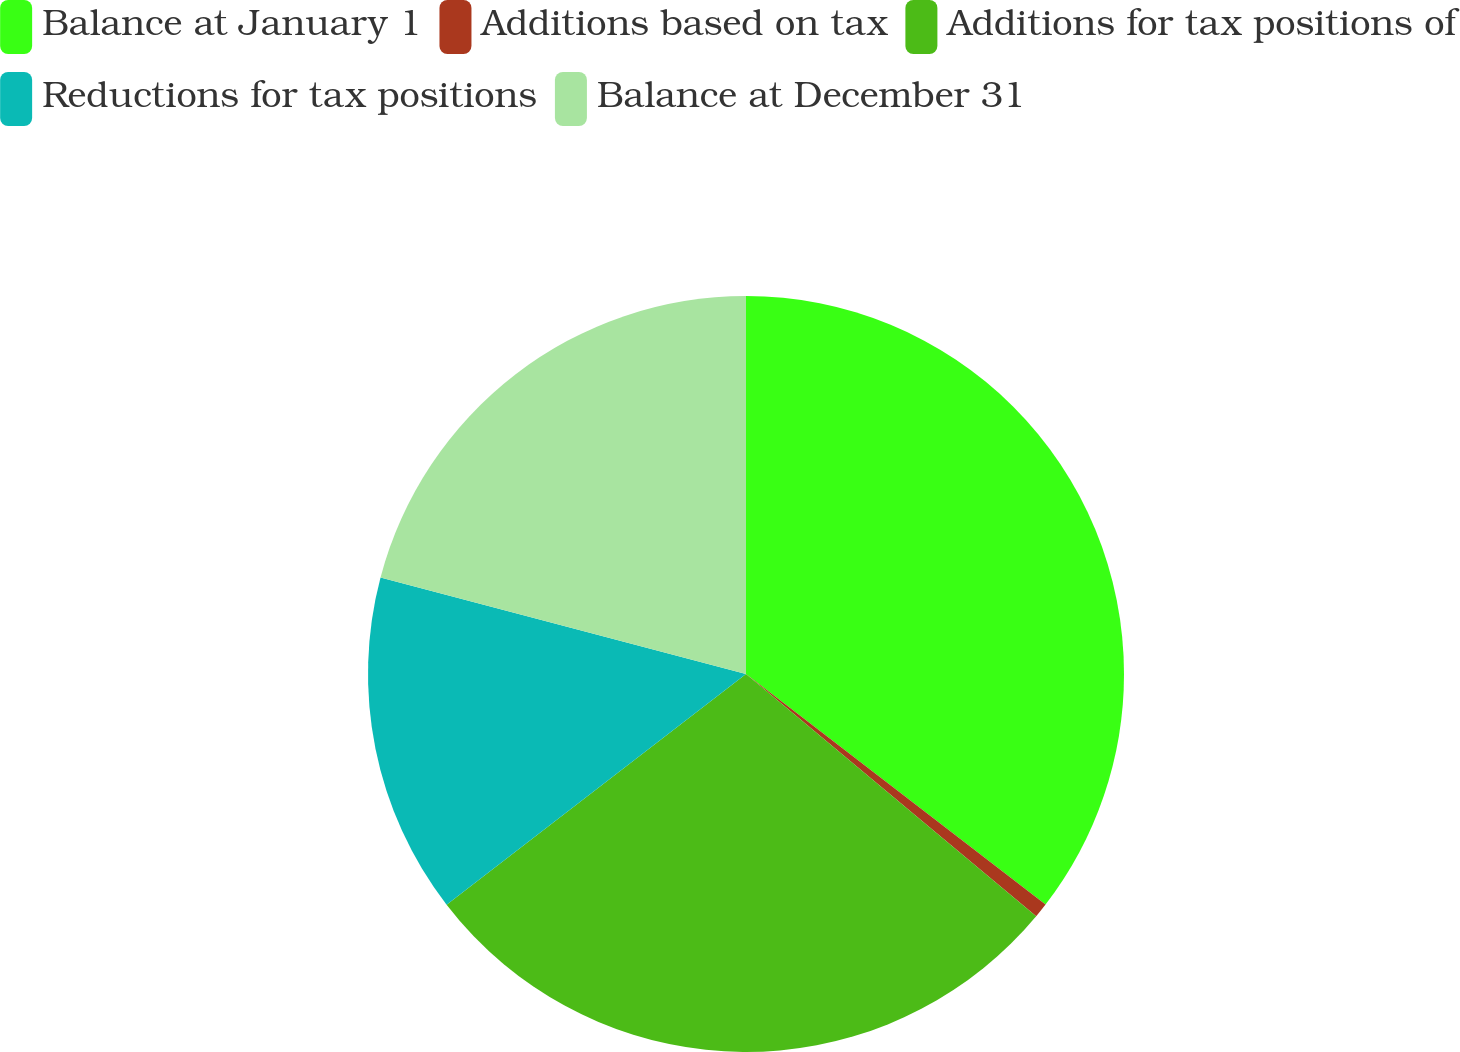<chart> <loc_0><loc_0><loc_500><loc_500><pie_chart><fcel>Balance at January 1<fcel>Additions based on tax<fcel>Additions for tax positions of<fcel>Reductions for tax positions<fcel>Balance at December 31<nl><fcel>35.44%<fcel>0.63%<fcel>28.48%<fcel>14.56%<fcel>20.89%<nl></chart> 